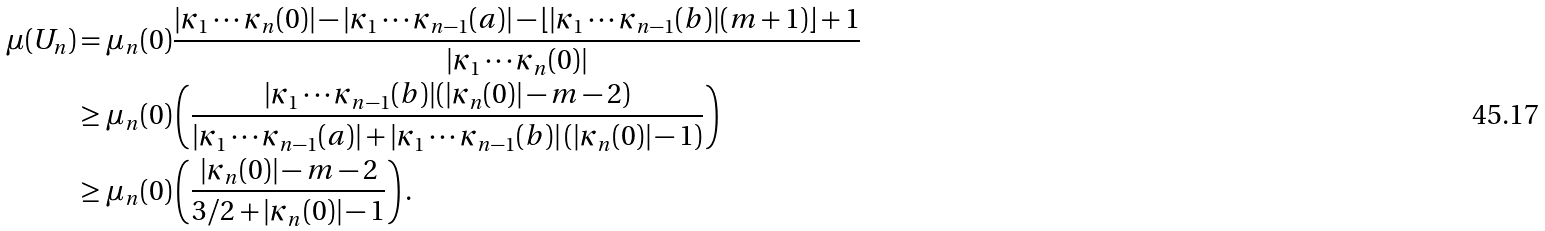Convert formula to latex. <formula><loc_0><loc_0><loc_500><loc_500>\mu ( U _ { n } ) & = \mu _ { n } ( 0 ) \frac { | \kappa _ { 1 } \cdots \kappa _ { n } ( 0 ) | - | \kappa _ { 1 } \cdots \kappa _ { n - 1 } ( a ) | - \lfloor | \kappa _ { 1 } \cdots \kappa _ { n - 1 } ( b ) | ( m + 1 ) \rfloor + 1 } { | \kappa _ { 1 } \cdots \kappa _ { n } ( 0 ) | } \\ & \geq \mu _ { n } ( 0 ) \left ( \frac { | \kappa _ { 1 } \cdots \kappa _ { n - 1 } ( b ) | ( | \kappa _ { n } ( 0 ) | - m - 2 ) } { | \kappa _ { 1 } \cdots \kappa _ { n - 1 } ( a ) | + | \kappa _ { 1 } \cdots \kappa _ { n - 1 } ( b ) | \left ( | \kappa _ { n } ( 0 ) | - 1 \right ) } \right ) \\ & \geq \mu _ { n } ( 0 ) \left ( \frac { | \kappa _ { n } ( 0 ) | - m - 2 } { 3 / 2 + | \kappa _ { n } ( 0 ) | - 1 } \right ) .</formula> 